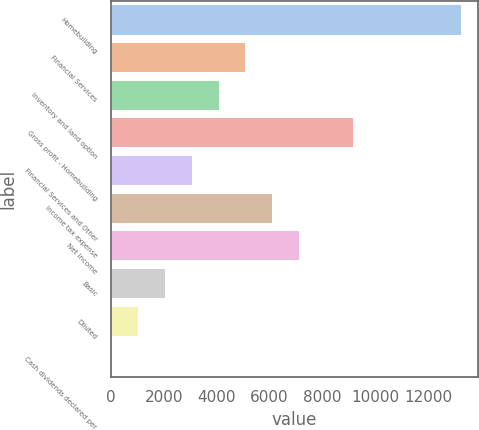Convert chart to OTSL. <chart><loc_0><loc_0><loc_500><loc_500><bar_chart><fcel>Homebuilding<fcel>Financial Services<fcel>Inventory and land option<fcel>Gross profit - Homebuilding<fcel>Financial Services and Other<fcel>Income tax expense<fcel>Net income<fcel>Basic<fcel>Diluted<fcel>Cash dividends declared per<nl><fcel>13241<fcel>5092.79<fcel>4074.26<fcel>9166.91<fcel>3055.73<fcel>6111.32<fcel>7129.85<fcel>2037.2<fcel>1018.67<fcel>0.14<nl></chart> 